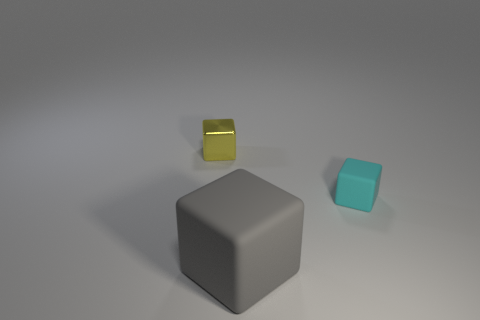What number of large cyan cubes are there?
Your answer should be compact. 0. What number of tiny objects are either cyan matte blocks or metallic objects?
Make the answer very short. 2. Is there anything else that is the same size as the shiny cube?
Give a very brief answer. Yes. There is a object that is behind the small block that is in front of the small yellow thing; what is it made of?
Your answer should be very brief. Metal. Does the cyan rubber object have the same size as the gray thing?
Provide a succinct answer. No. What number of objects are either objects that are behind the big matte block or gray shiny cylinders?
Offer a terse response. 2. The tiny thing that is right of the thing that is to the left of the large gray object is what shape?
Your answer should be very brief. Cube. There is a yellow metallic cube; is its size the same as the block on the right side of the large gray rubber cube?
Keep it short and to the point. Yes. What is the material of the tiny cube on the left side of the tiny rubber thing?
Your answer should be compact. Metal. What number of things are both behind the large gray block and on the right side of the yellow shiny block?
Offer a terse response. 1. 